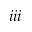Convert formula to latex. <formula><loc_0><loc_0><loc_500><loc_500>i i i</formula> 